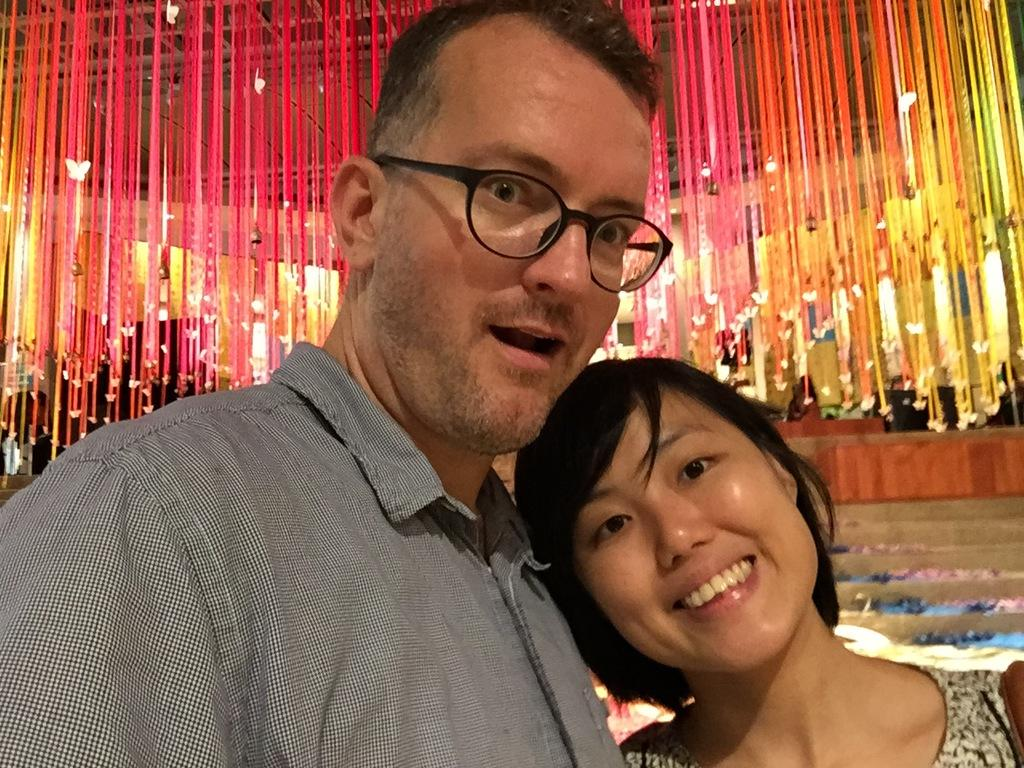How many people are present in the image? There are two people, a man and a woman, present in the image. What are the man and woman doing in the image? The man and woman are standing in the image. What can be seen in the background of the image? There are stairs and decorative items hanging from the ceiling in the background of the image. What is the annual income of the man and woman in the image? There is no information about the man and woman's income in the image, as it does not contain any details about their financial situation. 